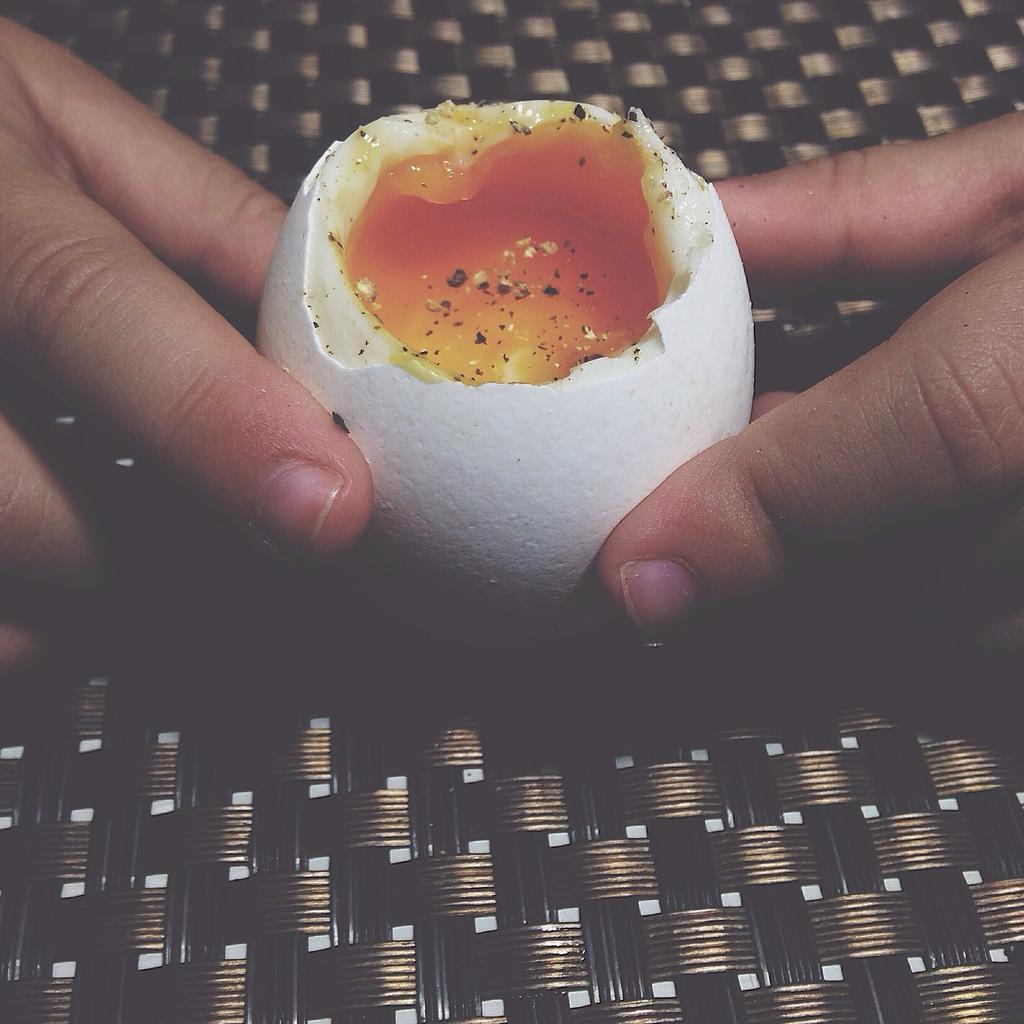What is the condition of the egg in the image? There is a broken egg in the image. What color is the yolk of the egg? The yolk of the egg is yellow. Who is holding the egg in the image? The egg is held by two hands. What is the color and design of the surface the hands are on? The hands are on a black carpet with a design. What type of soup is being prepared in the image? There is no soup present in the image; it features a broken egg held by two hands on a black carpet. What month is it in the image? The image does not provide any information about the month or time of year. 